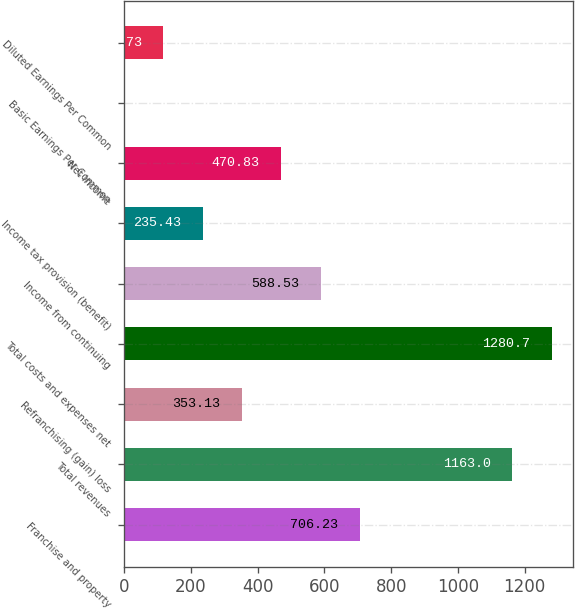Convert chart. <chart><loc_0><loc_0><loc_500><loc_500><bar_chart><fcel>Franchise and property<fcel>Total revenues<fcel>Refranchising (gain) loss<fcel>Total costs and expenses net<fcel>Income from continuing<fcel>Income tax provision (benefit)<fcel>Net Income<fcel>Basic Earnings Per Common<fcel>Diluted Earnings Per Common<nl><fcel>706.23<fcel>1163<fcel>353.13<fcel>1280.7<fcel>588.53<fcel>235.43<fcel>470.83<fcel>0.03<fcel>117.73<nl></chart> 